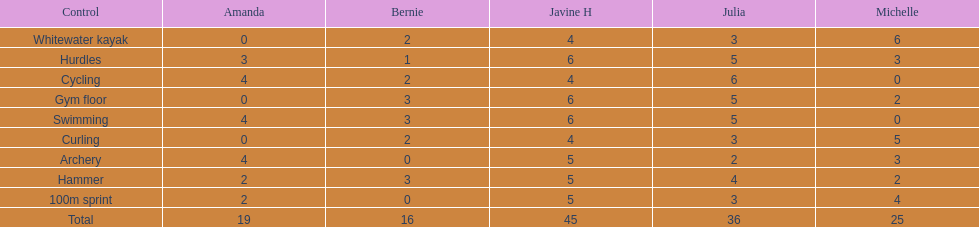Besides amanda, what other young woman also had a 4 in cycling? Javine H. 